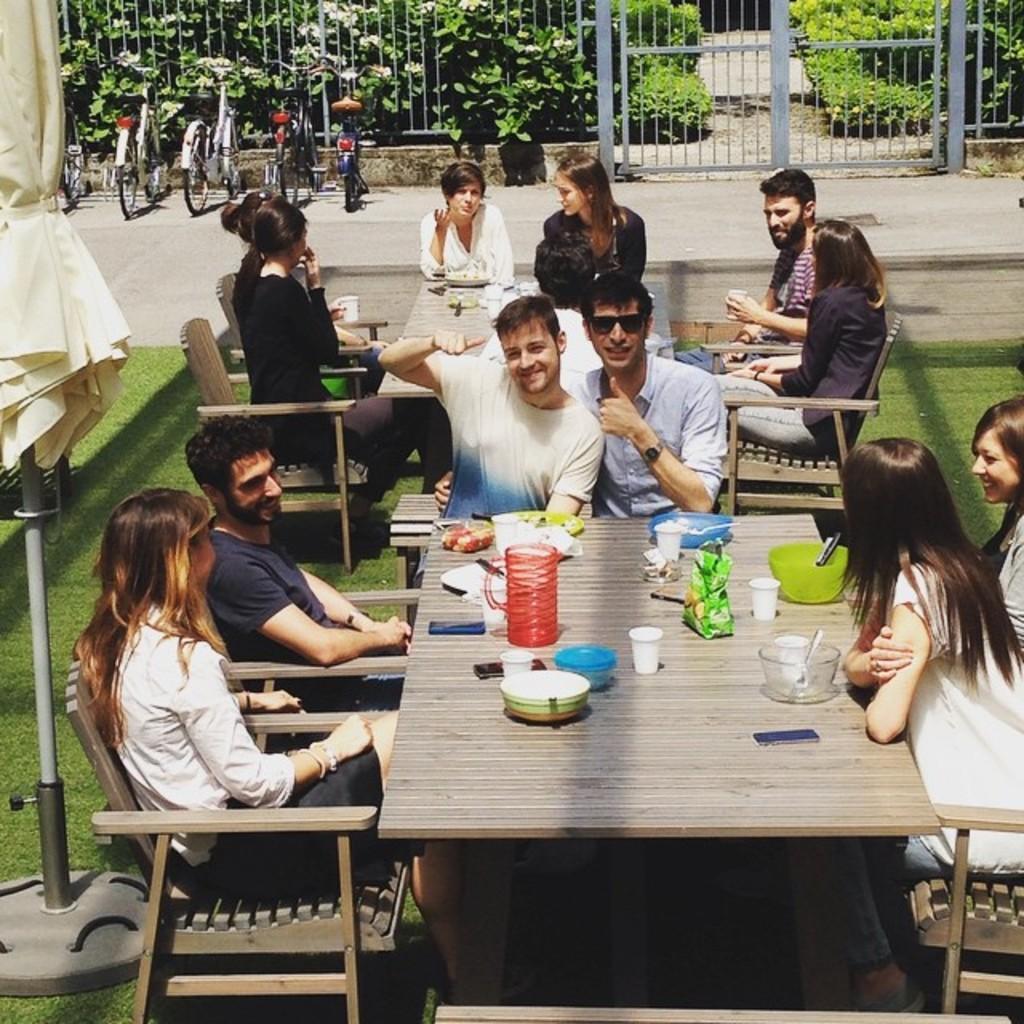Could you give a brief overview of what you see in this image? This is an outside View here I can see few people are sitting on the chairs around the table. In the background I can see few bicycles and plants. On the table there are some bowls, glasses and few objects. On the left side of the image I can see a pole. 